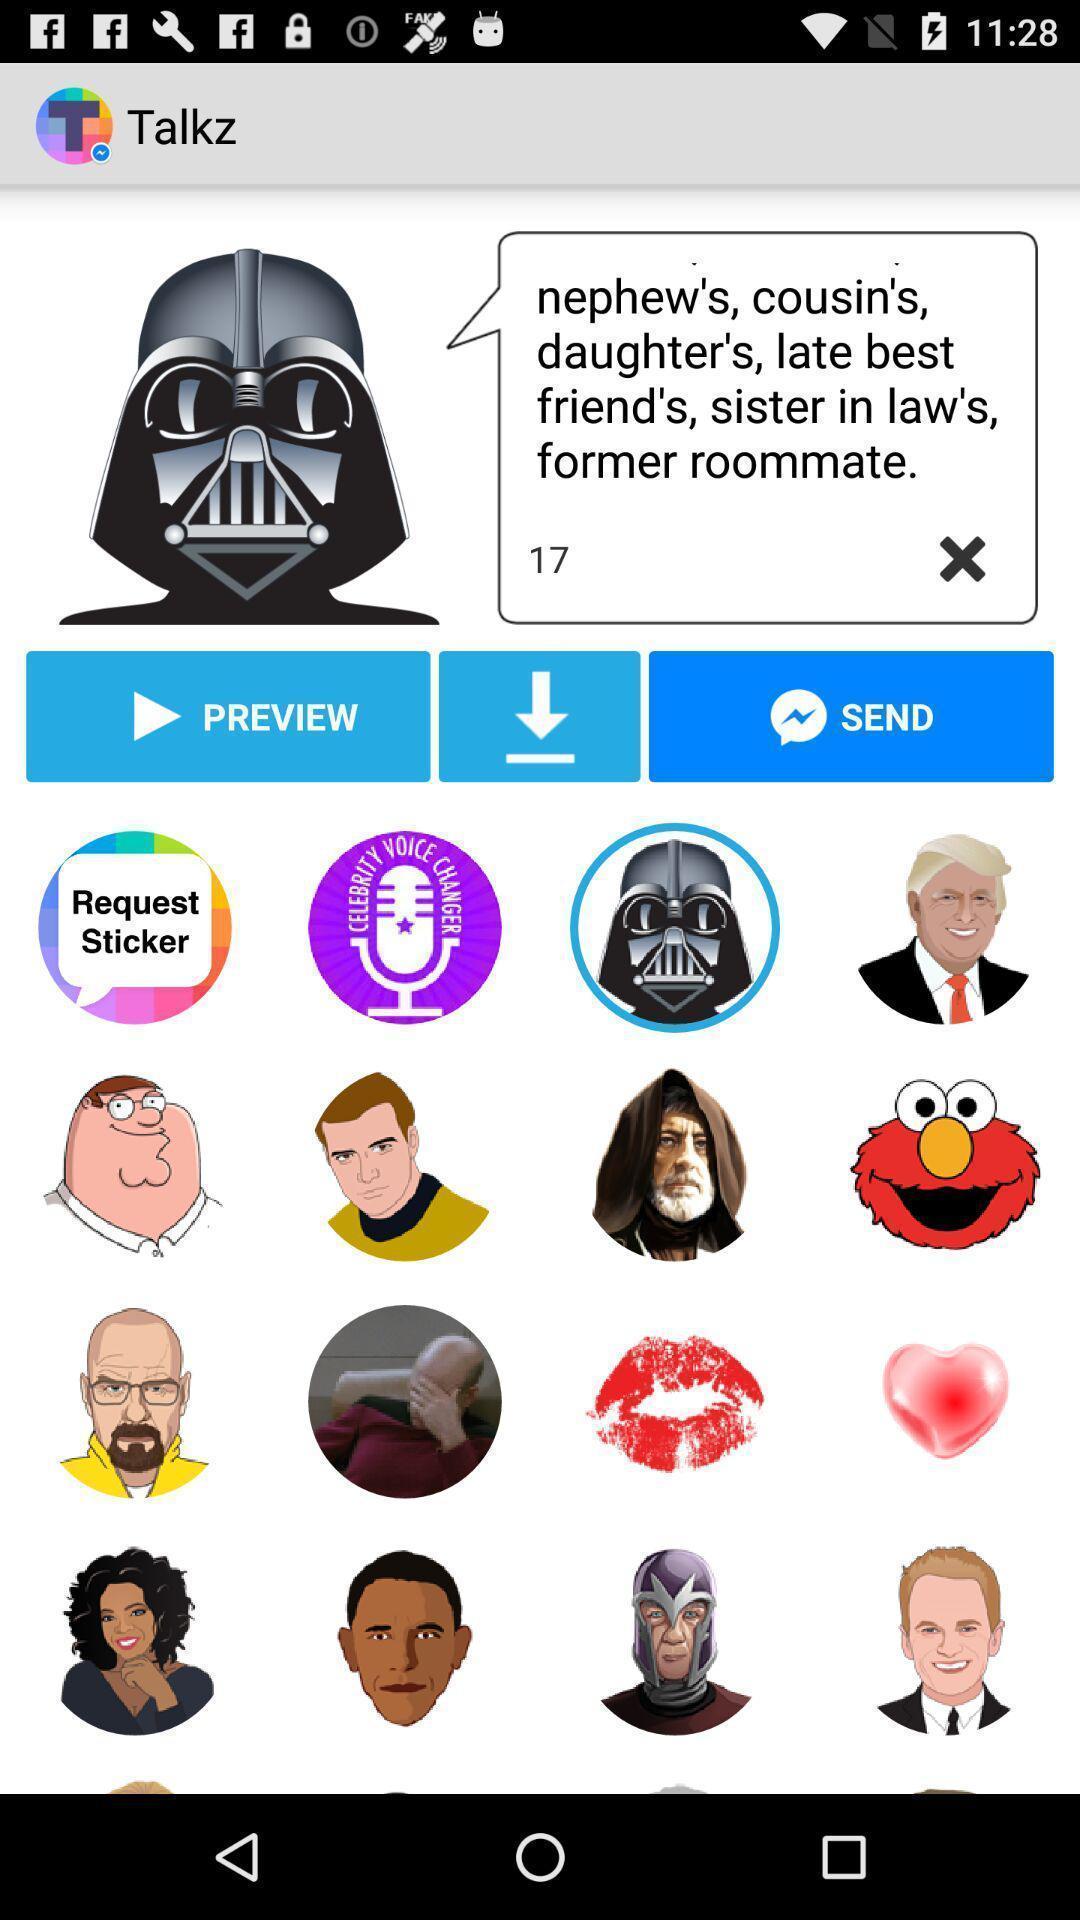Summarize the main components in this picture. Screen shows different stickers and options. 